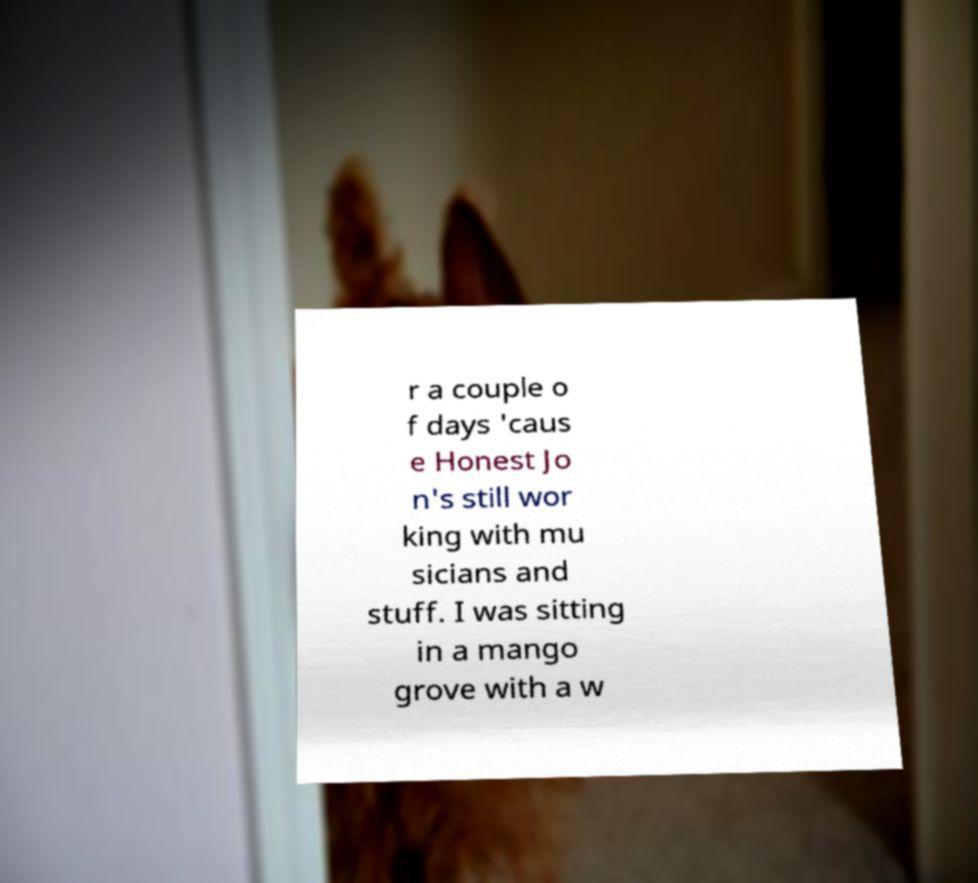What messages or text are displayed in this image? I need them in a readable, typed format. r a couple o f days 'caus e Honest Jo n's still wor king with mu sicians and stuff. I was sitting in a mango grove with a w 